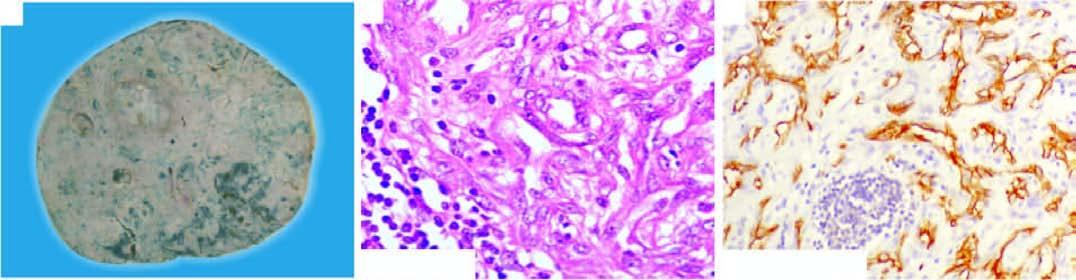what do these tumour cells show for endothelial marker, cd34?
Answer the question using a single word or phrase. Positive staining 